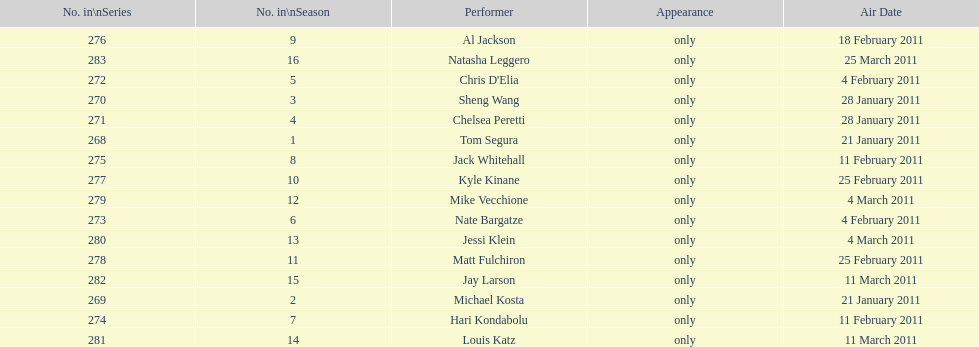Which month had the most performers? February. 